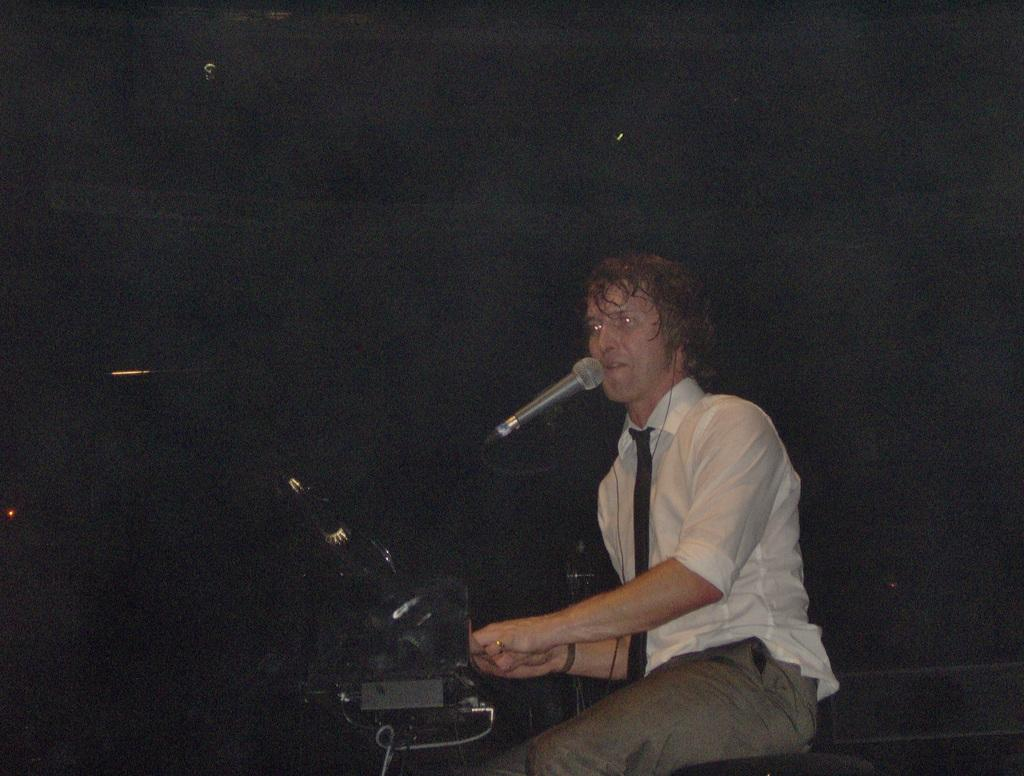What is the man in the image doing? The man is sitting on a stool in the image. What object is present that is commonly used for amplifying sound? There is a microphone (mike) in the image. What color is the man's shirt? The man is wearing a white shirt. What type of accessory is the man wearing around his neck? The man is wearing a tie. What type of clothing is the man wearing on his lower body? The man is wearing trousers. What color object can be seen in the image? There is a black color object in the image. How would you describe the lighting in the background of the image? The background of the image appears dark. Can you see a map on the wall behind the man? There is no map visible in the image. How does the feather help the man in the image? There is no feather present in the image, so it cannot help the man. 